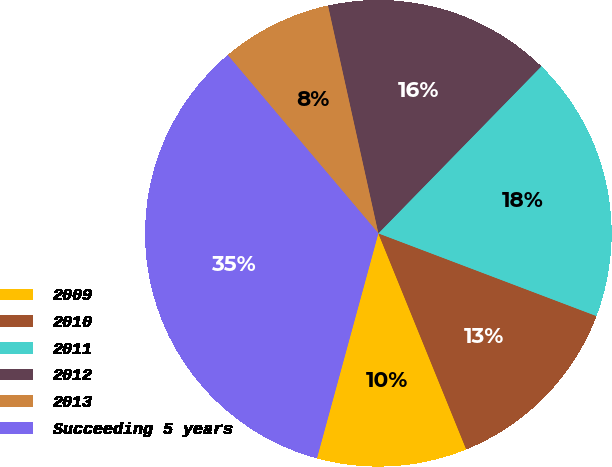<chart> <loc_0><loc_0><loc_500><loc_500><pie_chart><fcel>2009<fcel>2010<fcel>2011<fcel>2012<fcel>2013<fcel>Succeeding 5 years<nl><fcel>10.39%<fcel>13.08%<fcel>18.46%<fcel>15.77%<fcel>7.7%<fcel>34.59%<nl></chart> 